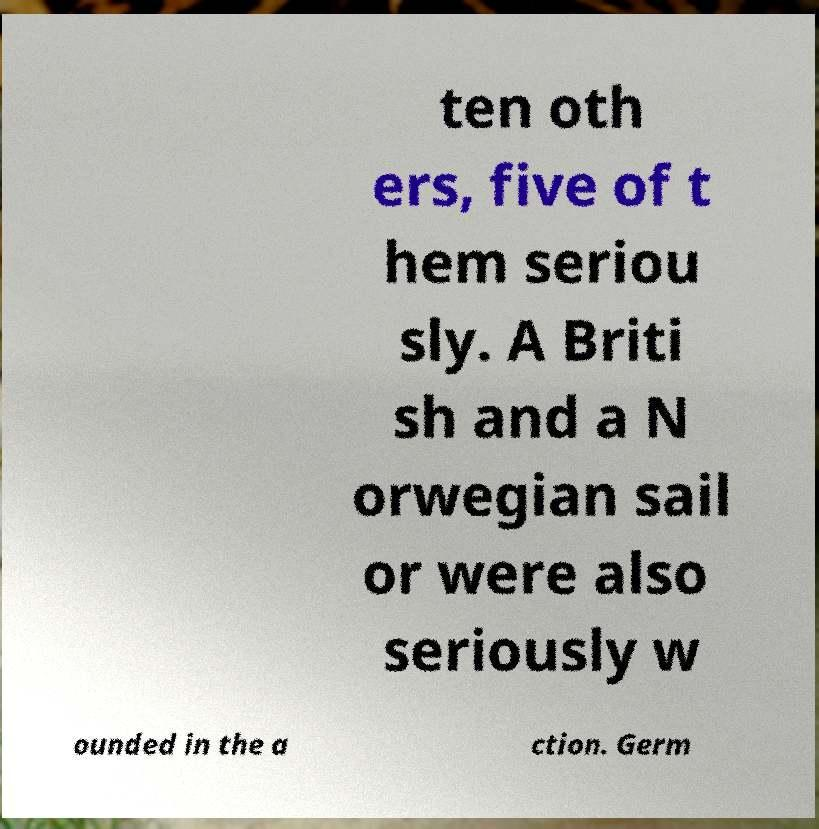Please read and relay the text visible in this image. What does it say? ten oth ers, five of t hem seriou sly. A Briti sh and a N orwegian sail or were also seriously w ounded in the a ction. Germ 